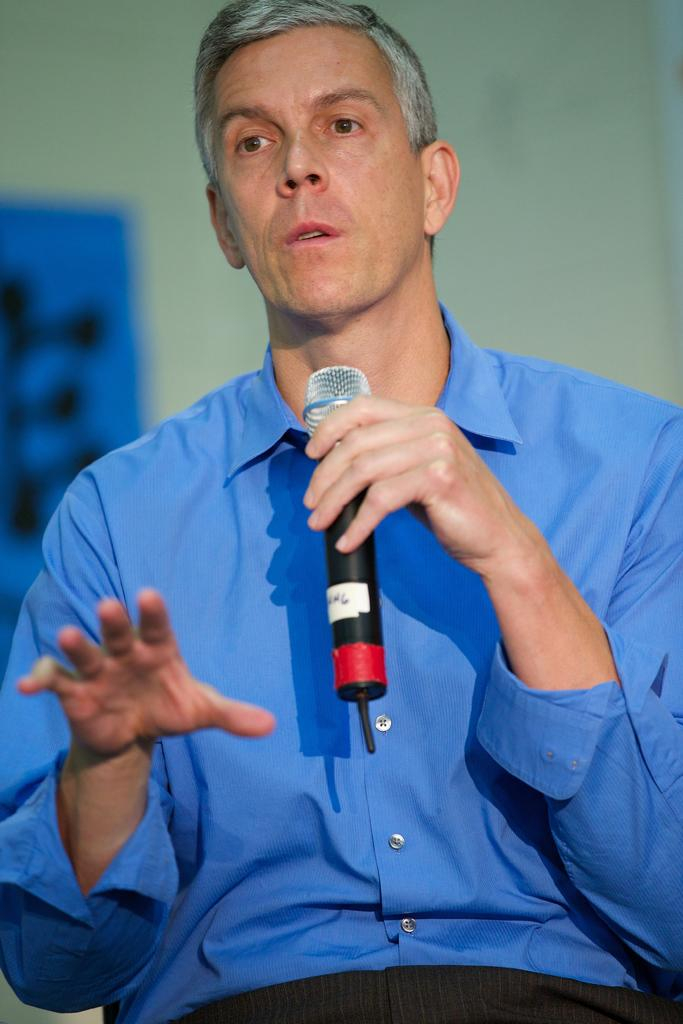Who is present in the image? There is a man in the image. What is the man doing in the image? The man is seated and speaking. What object is the man holding in the image? The man is holding a microphone. What verse is the man reciting in the image? There is no verse present in the image, as the man is holding a microphone and speaking, but no specific content is mentioned or visible. 